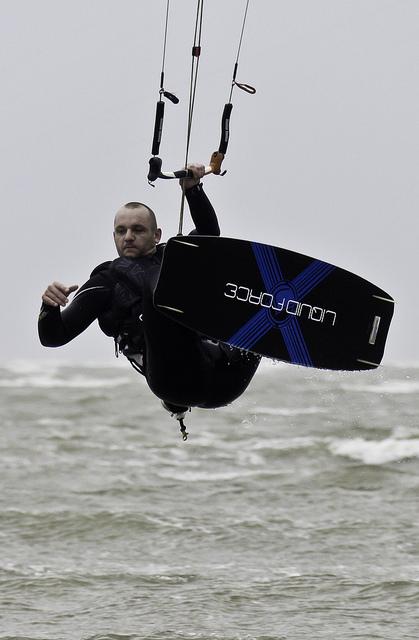Is this water calm?
Concise answer only. No. Is this wakeboarder currently in contact with the water?
Write a very short answer. No. Is it windy?
Short answer required. Yes. 